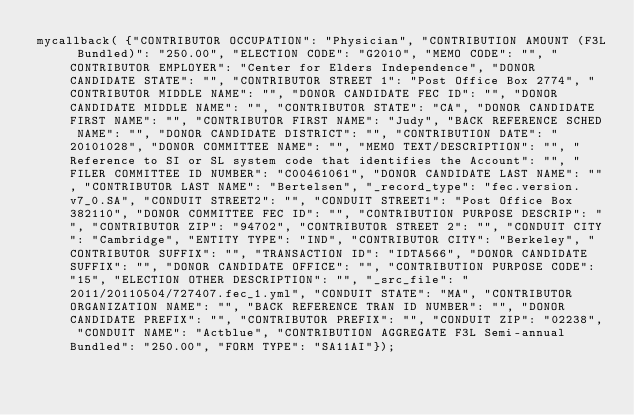Convert code to text. <code><loc_0><loc_0><loc_500><loc_500><_JavaScript_>mycallback( {"CONTRIBUTOR OCCUPATION": "Physician", "CONTRIBUTION AMOUNT (F3L Bundled)": "250.00", "ELECTION CODE": "G2010", "MEMO CODE": "", "CONTRIBUTOR EMPLOYER": "Center for Elders Independence", "DONOR CANDIDATE STATE": "", "CONTRIBUTOR STREET 1": "Post Office Box 2774", "CONTRIBUTOR MIDDLE NAME": "", "DONOR CANDIDATE FEC ID": "", "DONOR CANDIDATE MIDDLE NAME": "", "CONTRIBUTOR STATE": "CA", "DONOR CANDIDATE FIRST NAME": "", "CONTRIBUTOR FIRST NAME": "Judy", "BACK REFERENCE SCHED NAME": "", "DONOR CANDIDATE DISTRICT": "", "CONTRIBUTION DATE": "20101028", "DONOR COMMITTEE NAME": "", "MEMO TEXT/DESCRIPTION": "", "Reference to SI or SL system code that identifies the Account": "", "FILER COMMITTEE ID NUMBER": "C00461061", "DONOR CANDIDATE LAST NAME": "", "CONTRIBUTOR LAST NAME": "Bertelsen", "_record_type": "fec.version.v7_0.SA", "CONDUIT STREET2": "", "CONDUIT STREET1": "Post Office Box 382110", "DONOR COMMITTEE FEC ID": "", "CONTRIBUTION PURPOSE DESCRIP": "", "CONTRIBUTOR ZIP": "94702", "CONTRIBUTOR STREET 2": "", "CONDUIT CITY": "Cambridge", "ENTITY TYPE": "IND", "CONTRIBUTOR CITY": "Berkeley", "CONTRIBUTOR SUFFIX": "", "TRANSACTION ID": "IDTA566", "DONOR CANDIDATE SUFFIX": "", "DONOR CANDIDATE OFFICE": "", "CONTRIBUTION PURPOSE CODE": "15", "ELECTION OTHER DESCRIPTION": "", "_src_file": "2011/20110504/727407.fec_1.yml", "CONDUIT STATE": "MA", "CONTRIBUTOR ORGANIZATION NAME": "", "BACK REFERENCE TRAN ID NUMBER": "", "DONOR CANDIDATE PREFIX": "", "CONTRIBUTOR PREFIX": "", "CONDUIT ZIP": "02238", "CONDUIT NAME": "Actblue", "CONTRIBUTION AGGREGATE F3L Semi-annual Bundled": "250.00", "FORM TYPE": "SA11AI"});
</code> 